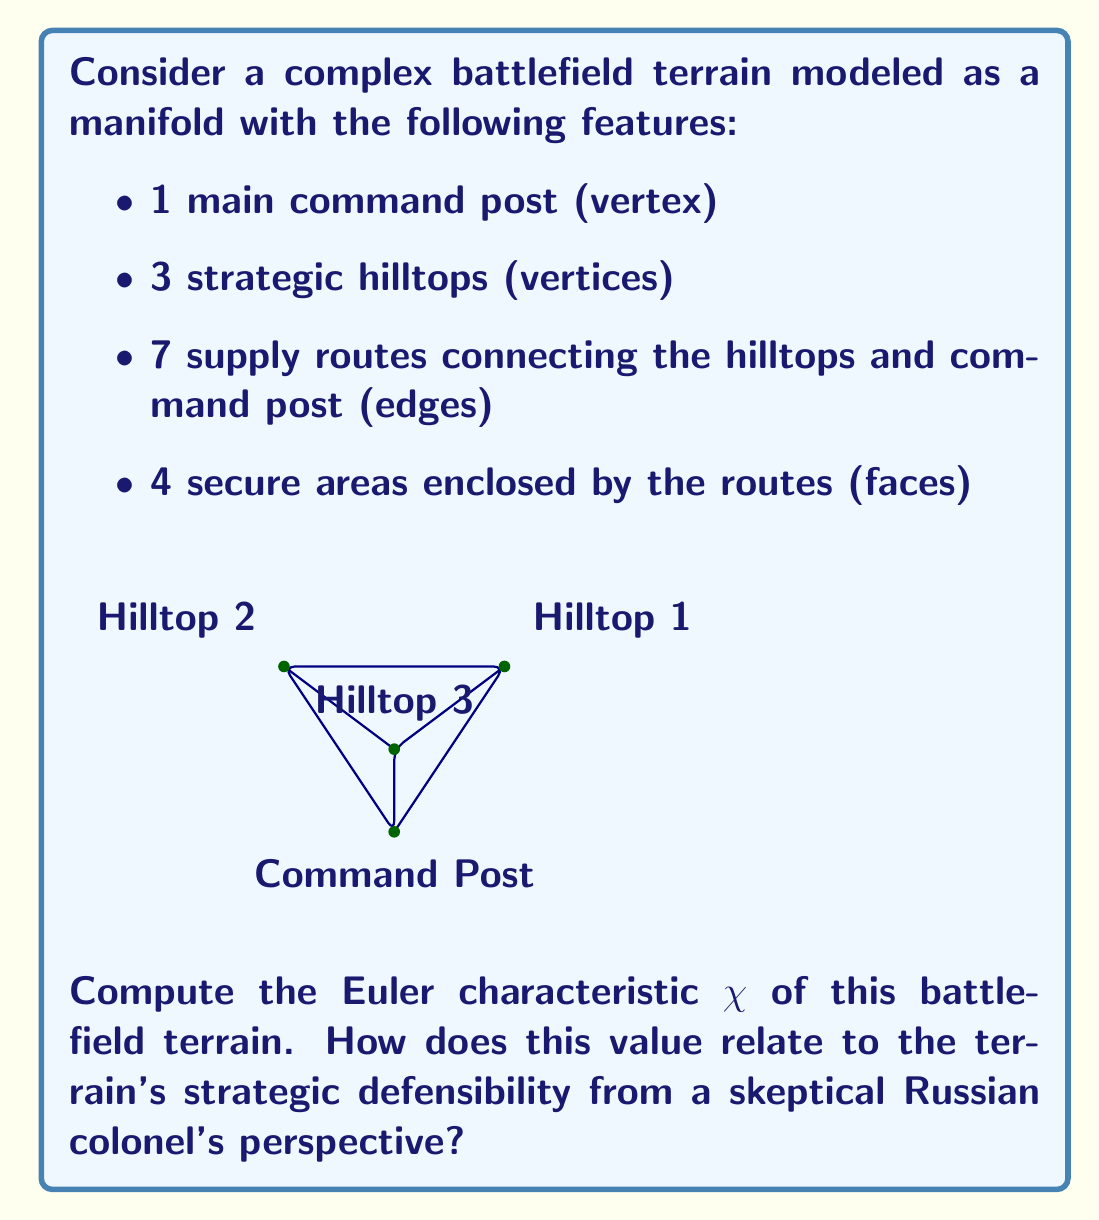Can you answer this question? To compute the Euler characteristic $\chi$ of the battlefield terrain, we use the formula:

$$\chi = V - E + F$$

Where:
$V$ = number of vertices
$E$ = number of edges
$F$ = number of faces

Step 1: Count the components
- Vertices (V): 1 command post + 3 hilltops = 4
- Edges (E): 7 supply routes
- Faces (F): 4 secure areas

Step 2: Apply the formula
$$\chi = 4 - 7 + 4 = 1$$

Step 3: Interpretation
The Euler characteristic of 1 indicates that this terrain is topologically equivalent to a disk or a sphere. From a skeptical Russian colonel's perspective, this could be interpreted as follows:

1. The positive Euler characteristic suggests a simply connected region, which might be easier to defend as there are no "holes" in the defensive perimeter.

2. However, the relatively low number of vertices (strategic points) compared to edges and faces might indicate a stretched defense, potentially vulnerable to NATO forces attempting to isolate individual positions.

3. The terrain's topology allows for multiple enclosed areas (faces), which could be used for secure staging grounds or as fallback positions in case of an attack.

4. The single command post connected to all hilltops provides centralized control but also represents a potential single point of failure if compromised.
Answer: $\chi = 1$ 